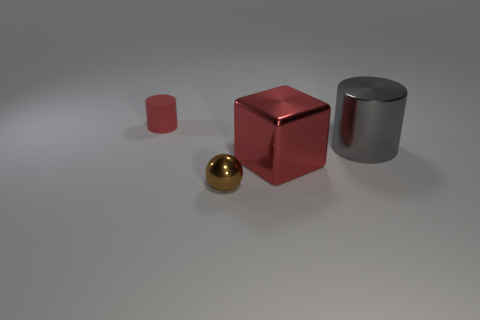Could you describe the lighting and shadows observed in the image? Certainly. The image exhibits a soft, diffused lighting that casts gentle shadows on the ground beneath each object. The directions of the shadows suggest a light source located above and to the right of the scene. The diffuse nature of the shadows indicates the light might be filtered through a medium like frosted glass, or it could represent an overcast sky if this were an outdoor scene. 